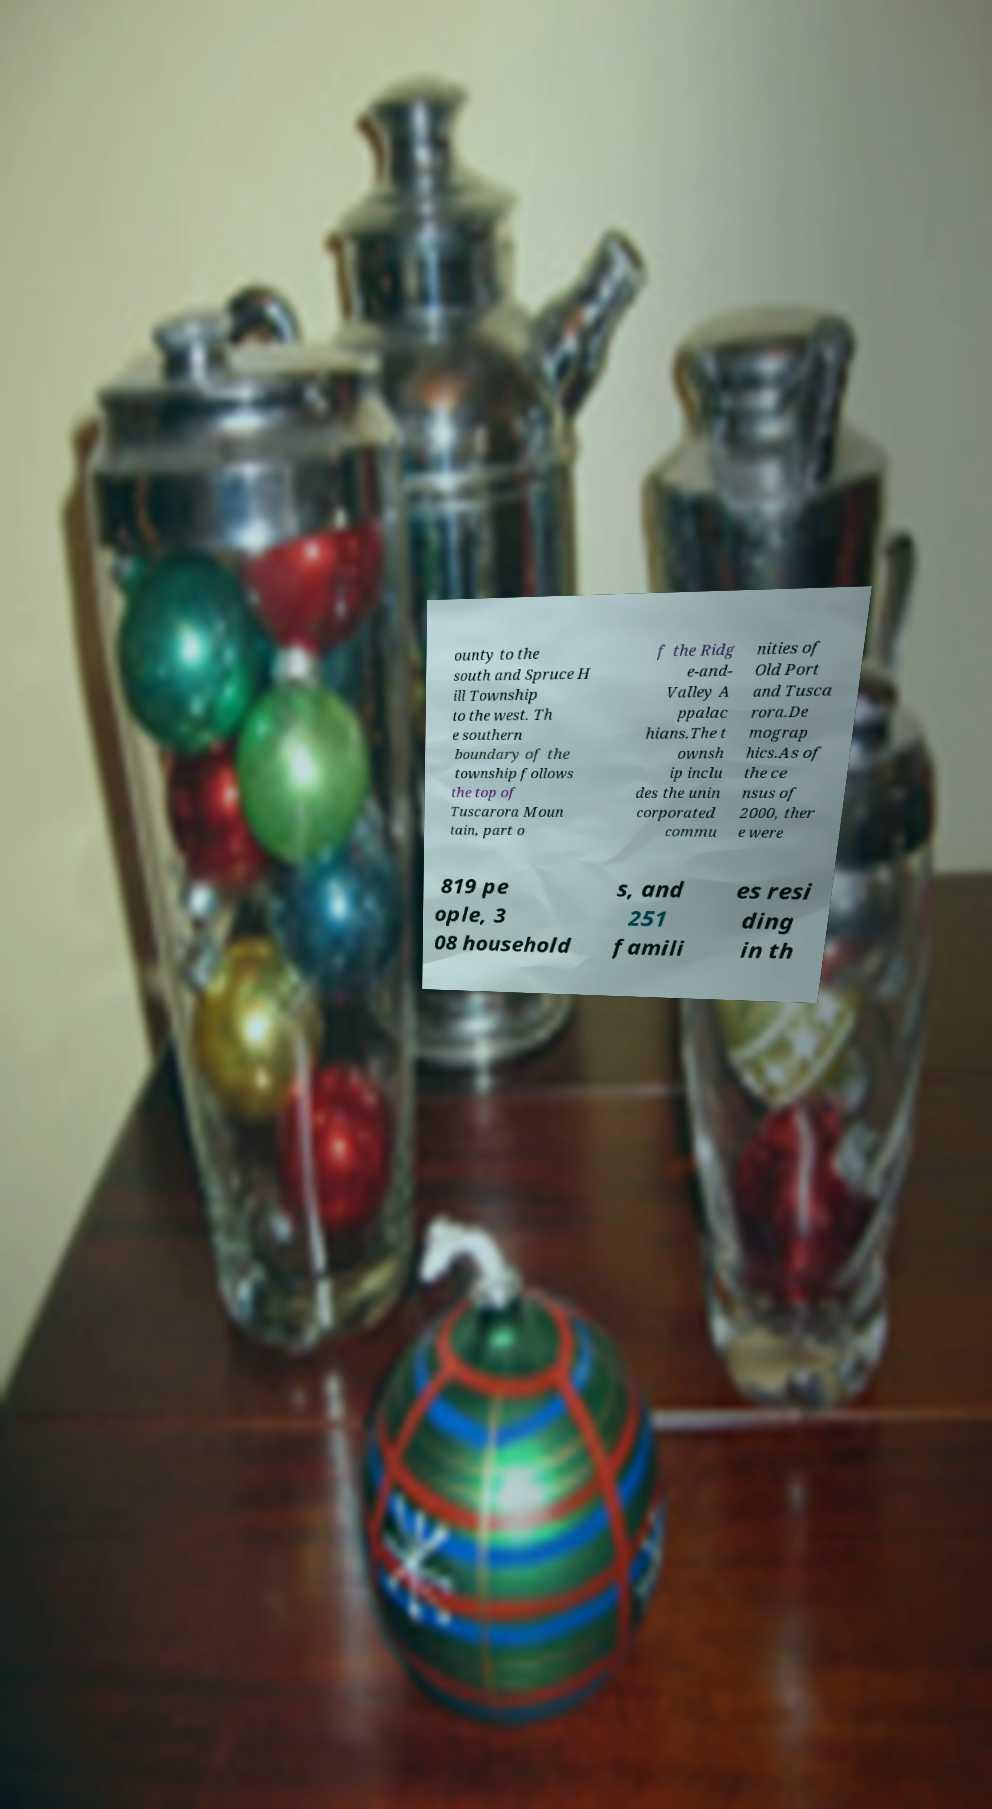There's text embedded in this image that I need extracted. Can you transcribe it verbatim? ounty to the south and Spruce H ill Township to the west. Th e southern boundary of the township follows the top of Tuscarora Moun tain, part o f the Ridg e-and- Valley A ppalac hians.The t ownsh ip inclu des the unin corporated commu nities of Old Port and Tusca rora.De mograp hics.As of the ce nsus of 2000, ther e were 819 pe ople, 3 08 household s, and 251 famili es resi ding in th 